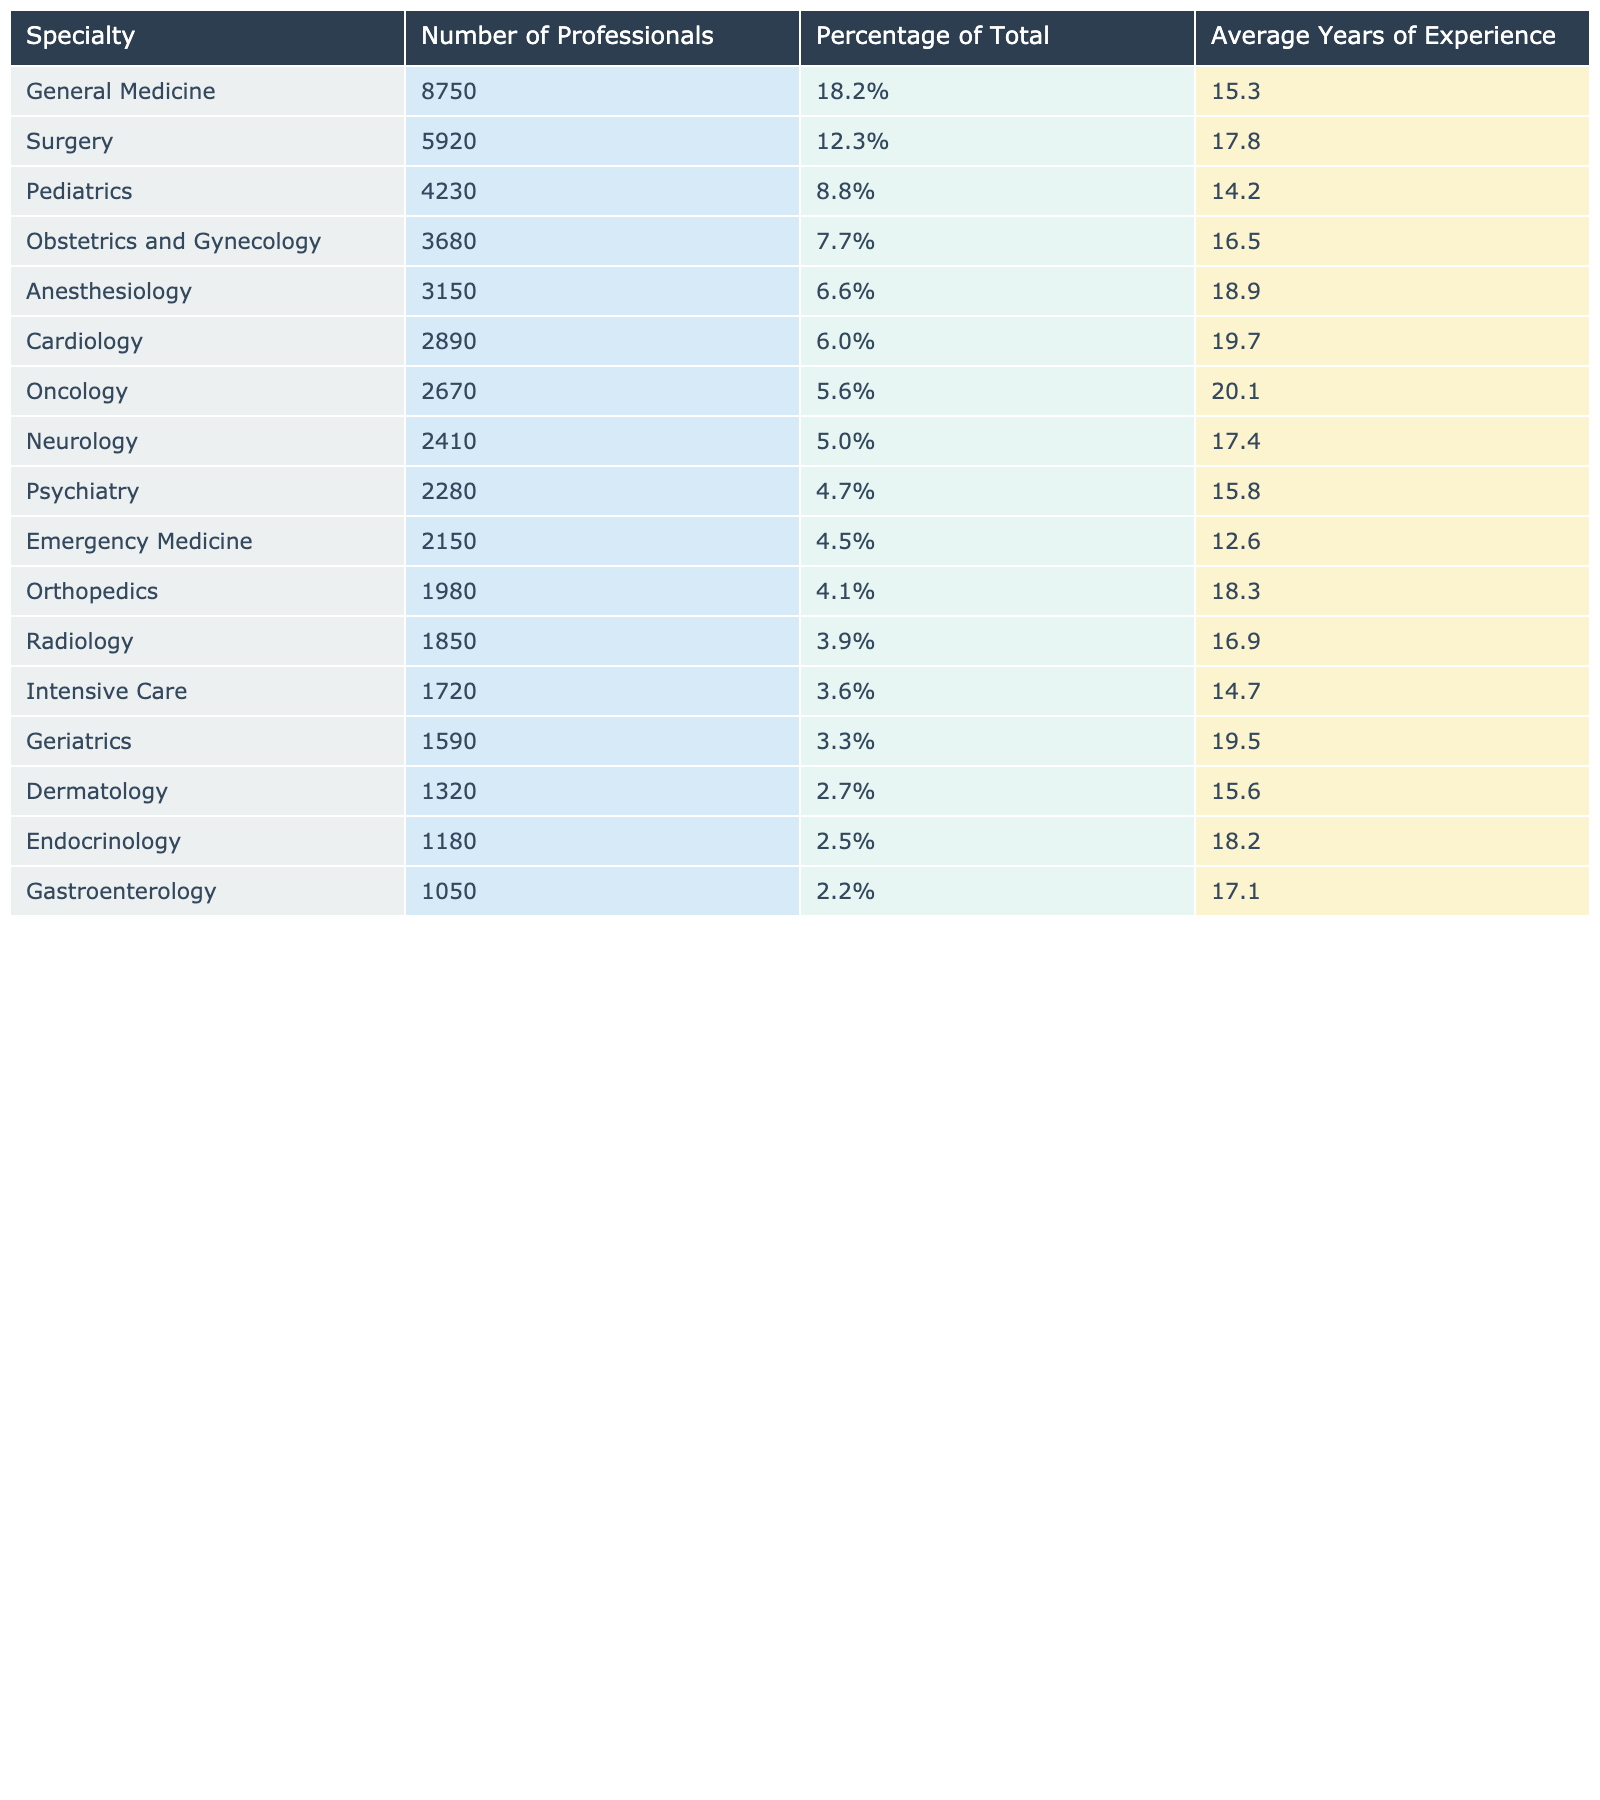What is the total number of healthcare professionals in General Medicine? The table indicates that there are 8750 healthcare professionals in the General Medicine specialty, which is listed directly in the "Number of Professionals" column.
Answer: 8750 What percentage of total healthcare professionals works in Surgery? The table shows that the percentage of healthcare professionals in Surgery is 12.3%, which is displayed in the "Percentage of Total" column next to Surgery.
Answer: 12.3% What is the average years of experience for professionals in Pediatrics? The average years of experience for professionals in Pediatrics is stated as 14.2 years in the "Average Years of Experience" column.
Answer: 14.2 Which specialty has the highest number of healthcare professionals? By examining the "Number of Professionals" column, General Medicine has the highest number of professionals at 8750, more than any other specialty listed.
Answer: General Medicine What is the total number of healthcare professionals in both Obstetrics and Gynecology and Anesthesiology? To find the total, add the number of professionals in Obstetrics and Gynecology (3680) and Anesthesiology (3150). The sum is 3680 + 3150 = 6830.
Answer: 6830 Is there a higher percentage of professionals in Cardiology than in Psychiatry? Looking at the percentages, Cardiology has 6.0% and Psychiatry has 4.7%. Since 6.0% is greater than 4.7%, the statement is true.
Answer: Yes What is the difference in average years of experience between Surgery and Dermatology? The average years of experience for Surgery is 17.8 years, and for Dermatology, it is 15.6 years. The difference is 17.8 - 15.6 = 2.2 years.
Answer: 2.2 years What are the top three specialties by the number of professionals? Sorting the "Number of Professionals" column, the top three specialties are General Medicine (8750), Surgery (5920), and Pediatrics (4230).
Answer: General Medicine, Surgery, Pediatrics How many professionals work in specialties with an average experience of over 18 years? The specialties include Anesthesiology (3150), Cardiology (2890), Oncology (2670), Neurology (2410), Geriatrics (1590), and Endocrinology (1180). Summing these gives 3150 + 2890 + 2670 + 2410 + 1590 + 1180 = 13980 professionals.
Answer: 13980 Which specialty has the lowest number of healthcare professionals? In the "Number of Professionals" column, Gastroenterology shows the lowest count with 1050 professionals.
Answer: Gastroenterology What is the total percentage of professionals in specialties related to women's health (Obstetrics and Gynecology, and Pediatrics)? The percentages for Obstetrics and Gynecology (7.7%) and Pediatrics (8.8%) should be added together: 7.7 + 8.8 = 16.5%.
Answer: 16.5% 